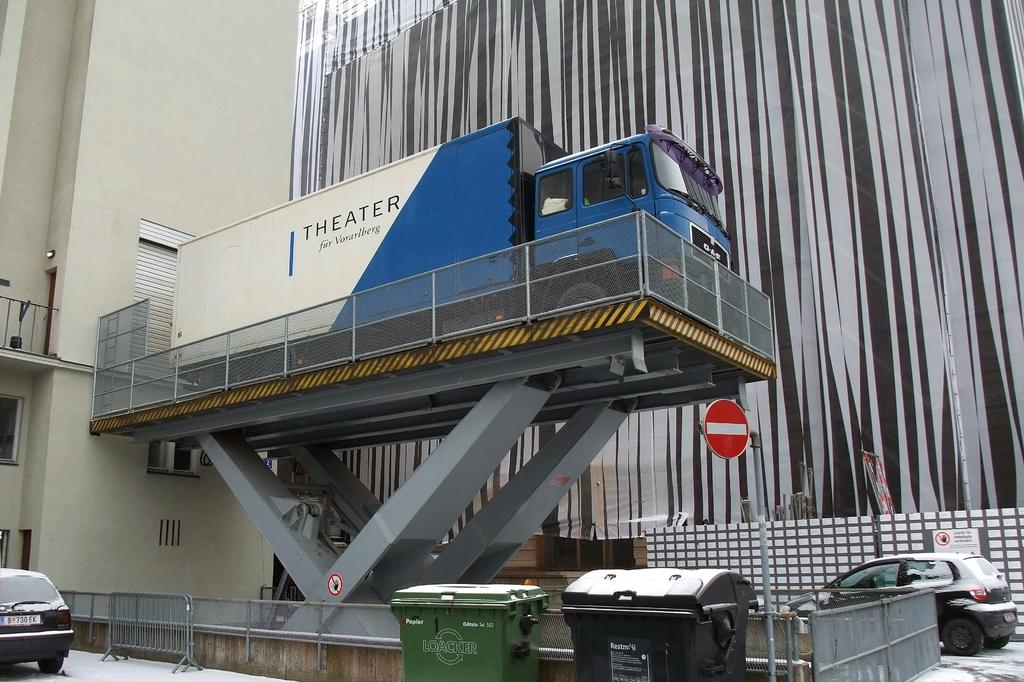<image>
Relay a brief, clear account of the picture shown. White and blue truck which says THEATER  on it. 